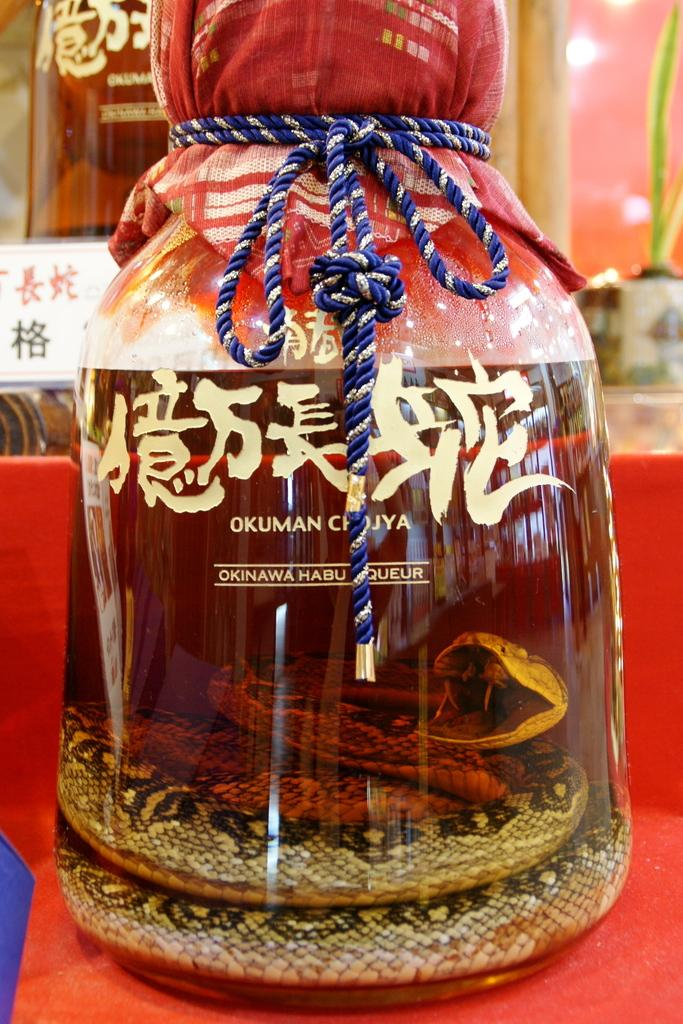What is located in the middle of the image? There is a bottle in the middle of the image. What is inside the bottle? There is a snake inside the bottle. How is the snake positioned in the bottle? The snake is tied. What can be seen in the background of the image? There are bottles in the background of the image. What type of moon can be seen in the image? There is no moon present in the image. Who is the judge in the image? There is no judge present in the image. 